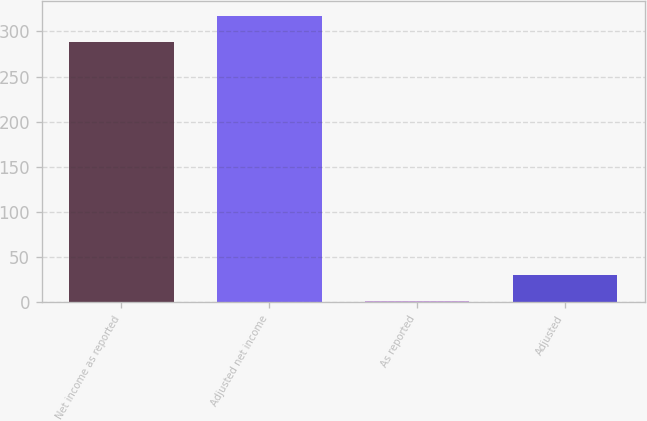<chart> <loc_0><loc_0><loc_500><loc_500><bar_chart><fcel>Net income as reported<fcel>Adjusted net income<fcel>As reported<fcel>Adjusted<nl><fcel>288.9<fcel>317.6<fcel>1.88<fcel>30.58<nl></chart> 